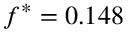Convert formula to latex. <formula><loc_0><loc_0><loc_500><loc_500>f ^ { * } = 0 . 1 4 8</formula> 